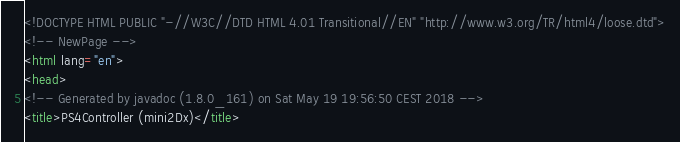<code> <loc_0><loc_0><loc_500><loc_500><_HTML_><!DOCTYPE HTML PUBLIC "-//W3C//DTD HTML 4.01 Transitional//EN" "http://www.w3.org/TR/html4/loose.dtd">
<!-- NewPage -->
<html lang="en">
<head>
<!-- Generated by javadoc (1.8.0_161) on Sat May 19 19:56:50 CEST 2018 -->
<title>PS4Controller (mini2Dx)</title></code> 